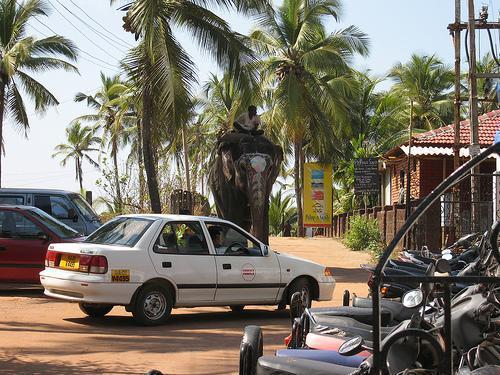How many elephants are there?
Give a very brief answer. 1. 